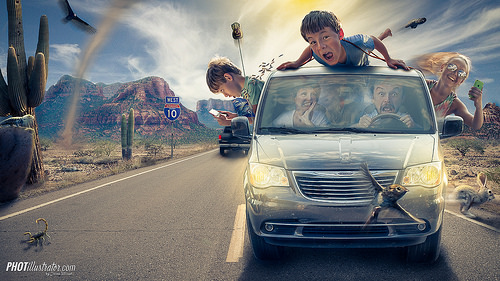<image>
Is there a man behind the car? No. The man is not behind the car. From this viewpoint, the man appears to be positioned elsewhere in the scene. 